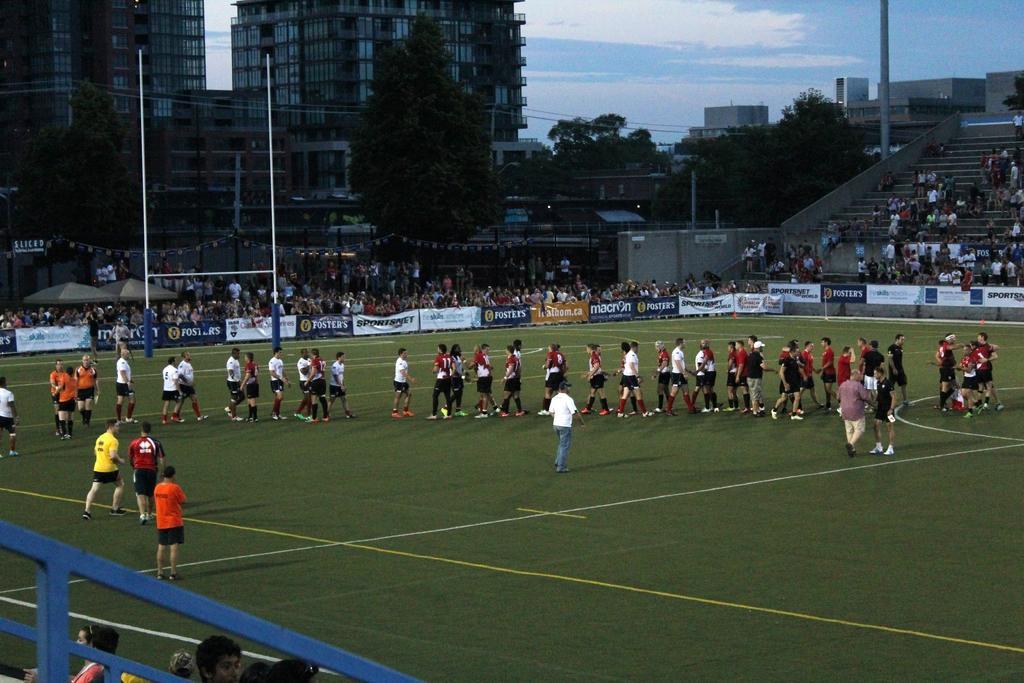Could you give a brief overview of what you see in this image? A picture of a stadium. Group of people are standing on a grass in a stadium. Banner over the stadium. Pole. Sky is in blue color. Building with glasses. Far there are trees. These are steps. Audience are observing match. 